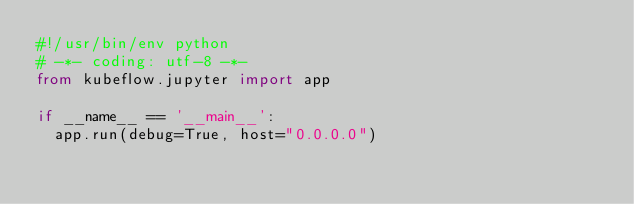<code> <loc_0><loc_0><loc_500><loc_500><_Python_>#!/usr/bin/env python
# -*- coding: utf-8 -*-
from kubeflow.jupyter import app

if __name__ == '__main__':
  app.run(debug=True, host="0.0.0.0")
</code> 